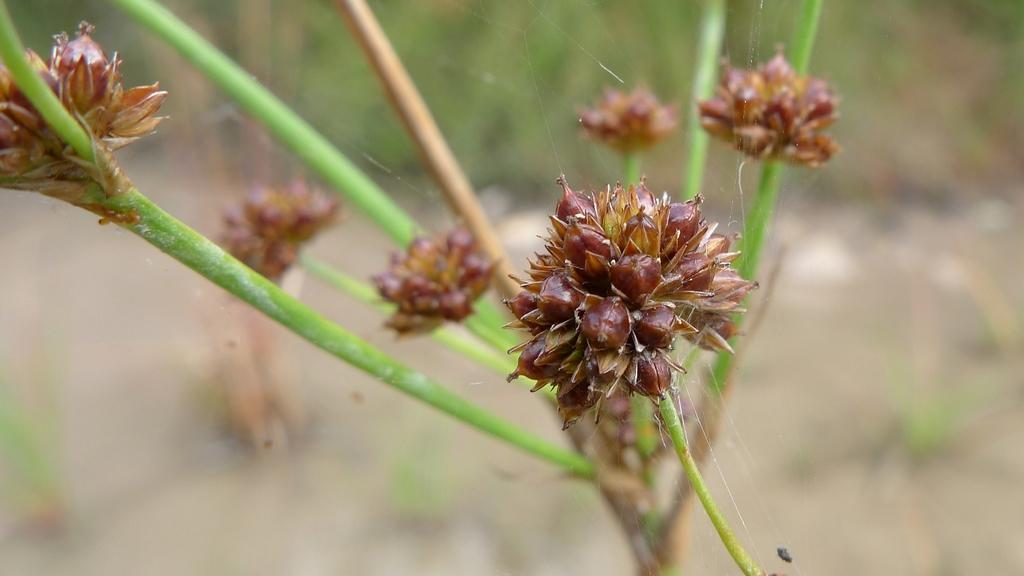What is the main subject of the image? The main subject of the image is a plant. How close is the camera to the plant in the image? The image is a zoomed in picture of the plant. What can be observed about the background of the image? The background of the image is blurred. What type of blade is being used to trim the plant in the image? There is no blade or trimming activity visible in the image; it is a zoomed in picture of a plant with a blurred background. 